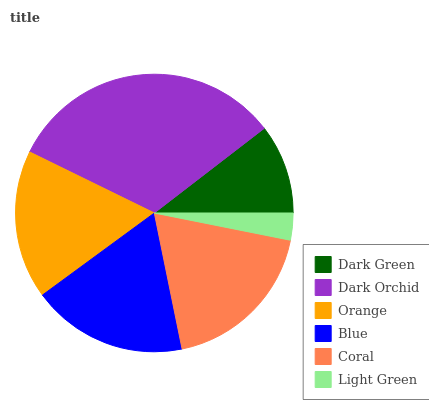Is Light Green the minimum?
Answer yes or no. Yes. Is Dark Orchid the maximum?
Answer yes or no. Yes. Is Orange the minimum?
Answer yes or no. No. Is Orange the maximum?
Answer yes or no. No. Is Dark Orchid greater than Orange?
Answer yes or no. Yes. Is Orange less than Dark Orchid?
Answer yes or no. Yes. Is Orange greater than Dark Orchid?
Answer yes or no. No. Is Dark Orchid less than Orange?
Answer yes or no. No. Is Blue the high median?
Answer yes or no. Yes. Is Orange the low median?
Answer yes or no. Yes. Is Dark Orchid the high median?
Answer yes or no. No. Is Blue the low median?
Answer yes or no. No. 